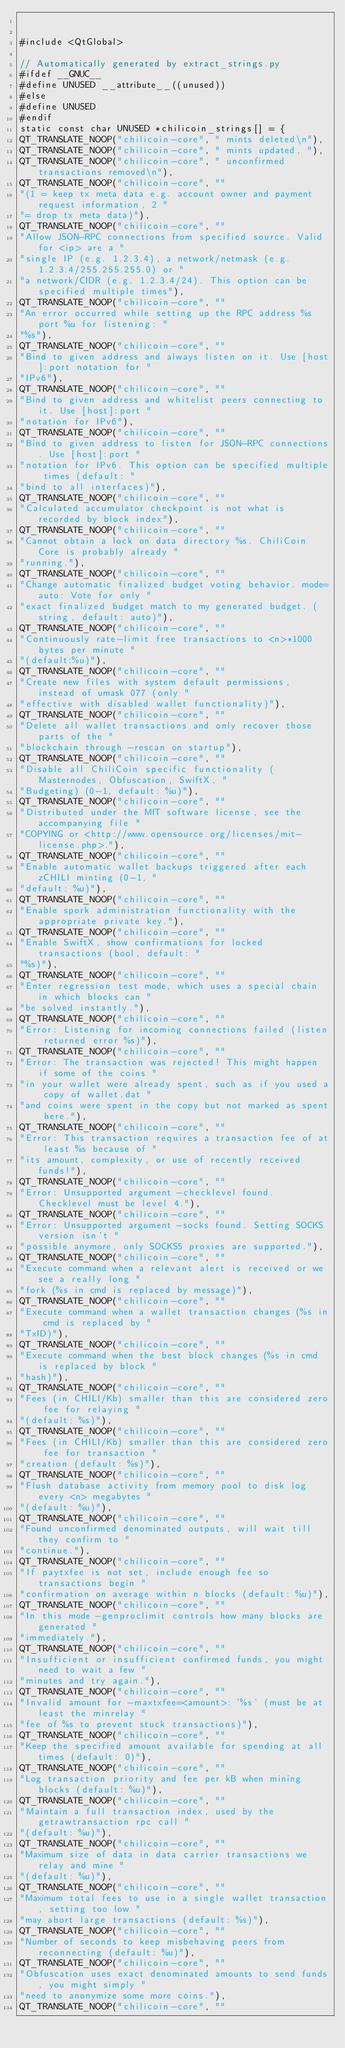<code> <loc_0><loc_0><loc_500><loc_500><_C++_>

#include <QtGlobal>

// Automatically generated by extract_strings.py
#ifdef __GNUC__
#define UNUSED __attribute__((unused))
#else
#define UNUSED
#endif
static const char UNUSED *chilicoin_strings[] = {
QT_TRANSLATE_NOOP("chilicoin-core", " mints deleted\n"),
QT_TRANSLATE_NOOP("chilicoin-core", " mints updated, "),
QT_TRANSLATE_NOOP("chilicoin-core", " unconfirmed transactions removed\n"),
QT_TRANSLATE_NOOP("chilicoin-core", ""
"(1 = keep tx meta data e.g. account owner and payment request information, 2 "
"= drop tx meta data)"),
QT_TRANSLATE_NOOP("chilicoin-core", ""
"Allow JSON-RPC connections from specified source. Valid for <ip> are a "
"single IP (e.g. 1.2.3.4), a network/netmask (e.g. 1.2.3.4/255.255.255.0) or "
"a network/CIDR (e.g. 1.2.3.4/24). This option can be specified multiple times"),
QT_TRANSLATE_NOOP("chilicoin-core", ""
"An error occurred while setting up the RPC address %s port %u for listening: "
"%s"),
QT_TRANSLATE_NOOP("chilicoin-core", ""
"Bind to given address and always listen on it. Use [host]:port notation for "
"IPv6"),
QT_TRANSLATE_NOOP("chilicoin-core", ""
"Bind to given address and whitelist peers connecting to it. Use [host]:port "
"notation for IPv6"),
QT_TRANSLATE_NOOP("chilicoin-core", ""
"Bind to given address to listen for JSON-RPC connections. Use [host]:port "
"notation for IPv6. This option can be specified multiple times (default: "
"bind to all interfaces)"),
QT_TRANSLATE_NOOP("chilicoin-core", ""
"Calculated accumulator checkpoint is not what is recorded by block index"),
QT_TRANSLATE_NOOP("chilicoin-core", ""
"Cannot obtain a lock on data directory %s. ChiliCoin Core is probably already "
"running."),
QT_TRANSLATE_NOOP("chilicoin-core", ""
"Change automatic finalized budget voting behavior. mode=auto: Vote for only "
"exact finalized budget match to my generated budget. (string, default: auto)"),
QT_TRANSLATE_NOOP("chilicoin-core", ""
"Continuously rate-limit free transactions to <n>*1000 bytes per minute "
"(default:%u)"),
QT_TRANSLATE_NOOP("chilicoin-core", ""
"Create new files with system default permissions, instead of umask 077 (only "
"effective with disabled wallet functionality)"),
QT_TRANSLATE_NOOP("chilicoin-core", ""
"Delete all wallet transactions and only recover those parts of the "
"blockchain through -rescan on startup"),
QT_TRANSLATE_NOOP("chilicoin-core", ""
"Disable all ChiliCoin specific functionality (Masternodes, Obfuscation, SwiftX, "
"Budgeting) (0-1, default: %u)"),
QT_TRANSLATE_NOOP("chilicoin-core", ""
"Distributed under the MIT software license, see the accompanying file "
"COPYING or <http://www.opensource.org/licenses/mit-license.php>."),
QT_TRANSLATE_NOOP("chilicoin-core", ""
"Enable automatic wallet backups triggered after each zCHILI minting (0-1, "
"default: %u)"),
QT_TRANSLATE_NOOP("chilicoin-core", ""
"Enable spork administration functionality with the appropriate private key."),
QT_TRANSLATE_NOOP("chilicoin-core", ""
"Enable SwiftX, show confirmations for locked transactions (bool, default: "
"%s)"),
QT_TRANSLATE_NOOP("chilicoin-core", ""
"Enter regression test mode, which uses a special chain in which blocks can "
"be solved instantly."),
QT_TRANSLATE_NOOP("chilicoin-core", ""
"Error: Listening for incoming connections failed (listen returned error %s)"),
QT_TRANSLATE_NOOP("chilicoin-core", ""
"Error: The transaction was rejected! This might happen if some of the coins "
"in your wallet were already spent, such as if you used a copy of wallet.dat "
"and coins were spent in the copy but not marked as spent here."),
QT_TRANSLATE_NOOP("chilicoin-core", ""
"Error: This transaction requires a transaction fee of at least %s because of "
"its amount, complexity, or use of recently received funds!"),
QT_TRANSLATE_NOOP("chilicoin-core", ""
"Error: Unsupported argument -checklevel found. Checklevel must be level 4."),
QT_TRANSLATE_NOOP("chilicoin-core", ""
"Error: Unsupported argument -socks found. Setting SOCKS version isn't "
"possible anymore, only SOCKS5 proxies are supported."),
QT_TRANSLATE_NOOP("chilicoin-core", ""
"Execute command when a relevant alert is received or we see a really long "
"fork (%s in cmd is replaced by message)"),
QT_TRANSLATE_NOOP("chilicoin-core", ""
"Execute command when a wallet transaction changes (%s in cmd is replaced by "
"TxID)"),
QT_TRANSLATE_NOOP("chilicoin-core", ""
"Execute command when the best block changes (%s in cmd is replaced by block "
"hash)"),
QT_TRANSLATE_NOOP("chilicoin-core", ""
"Fees (in CHILI/Kb) smaller than this are considered zero fee for relaying "
"(default: %s)"),
QT_TRANSLATE_NOOP("chilicoin-core", ""
"Fees (in CHILI/Kb) smaller than this are considered zero fee for transaction "
"creation (default: %s)"),
QT_TRANSLATE_NOOP("chilicoin-core", ""
"Flush database activity from memory pool to disk log every <n> megabytes "
"(default: %u)"),
QT_TRANSLATE_NOOP("chilicoin-core", ""
"Found unconfirmed denominated outputs, will wait till they confirm to "
"continue."),
QT_TRANSLATE_NOOP("chilicoin-core", ""
"If paytxfee is not set, include enough fee so transactions begin "
"confirmation on average within n blocks (default: %u)"),
QT_TRANSLATE_NOOP("chilicoin-core", ""
"In this mode -genproclimit controls how many blocks are generated "
"immediately."),
QT_TRANSLATE_NOOP("chilicoin-core", ""
"Insufficient or insufficient confirmed funds, you might need to wait a few "
"minutes and try again."),
QT_TRANSLATE_NOOP("chilicoin-core", ""
"Invalid amount for -maxtxfee=<amount>: '%s' (must be at least the minrelay "
"fee of %s to prevent stuck transactions)"),
QT_TRANSLATE_NOOP("chilicoin-core", ""
"Keep the specified amount available for spending at all times (default: 0)"),
QT_TRANSLATE_NOOP("chilicoin-core", ""
"Log transaction priority and fee per kB when mining blocks (default: %u)"),
QT_TRANSLATE_NOOP("chilicoin-core", ""
"Maintain a full transaction index, used by the getrawtransaction rpc call "
"(default: %u)"),
QT_TRANSLATE_NOOP("chilicoin-core", ""
"Maximum size of data in data carrier transactions we relay and mine "
"(default: %u)"),
QT_TRANSLATE_NOOP("chilicoin-core", ""
"Maximum total fees to use in a single wallet transaction, setting too low "
"may abort large transactions (default: %s)"),
QT_TRANSLATE_NOOP("chilicoin-core", ""
"Number of seconds to keep misbehaving peers from reconnecting (default: %u)"),
QT_TRANSLATE_NOOP("chilicoin-core", ""
"Obfuscation uses exact denominated amounts to send funds, you might simply "
"need to anonymize some more coins."),
QT_TRANSLATE_NOOP("chilicoin-core", ""</code> 